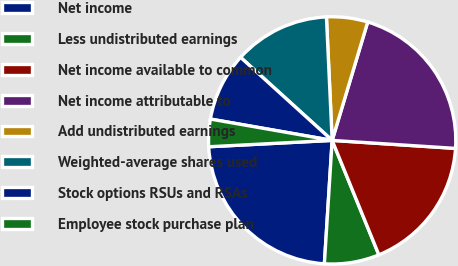Convert chart to OTSL. <chart><loc_0><loc_0><loc_500><loc_500><pie_chart><fcel>Net income<fcel>Less undistributed earnings<fcel>Net income available to common<fcel>Net income attributable to<fcel>Add undistributed earnings<fcel>Weighted-average shares used<fcel>Stock options RSUs and RSAs<fcel>Employee stock purchase plan<nl><fcel>23.18%<fcel>7.17%<fcel>17.8%<fcel>21.39%<fcel>5.38%<fcel>12.54%<fcel>8.96%<fcel>3.58%<nl></chart> 